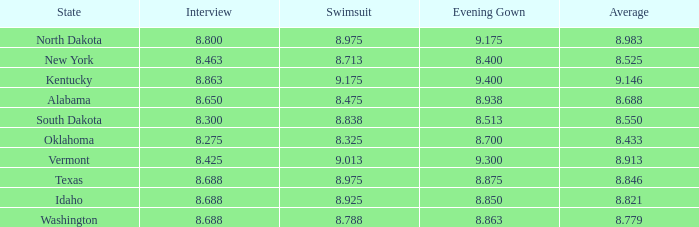Who obtained the minimum interview score from south dakota with an evening dress below None. 